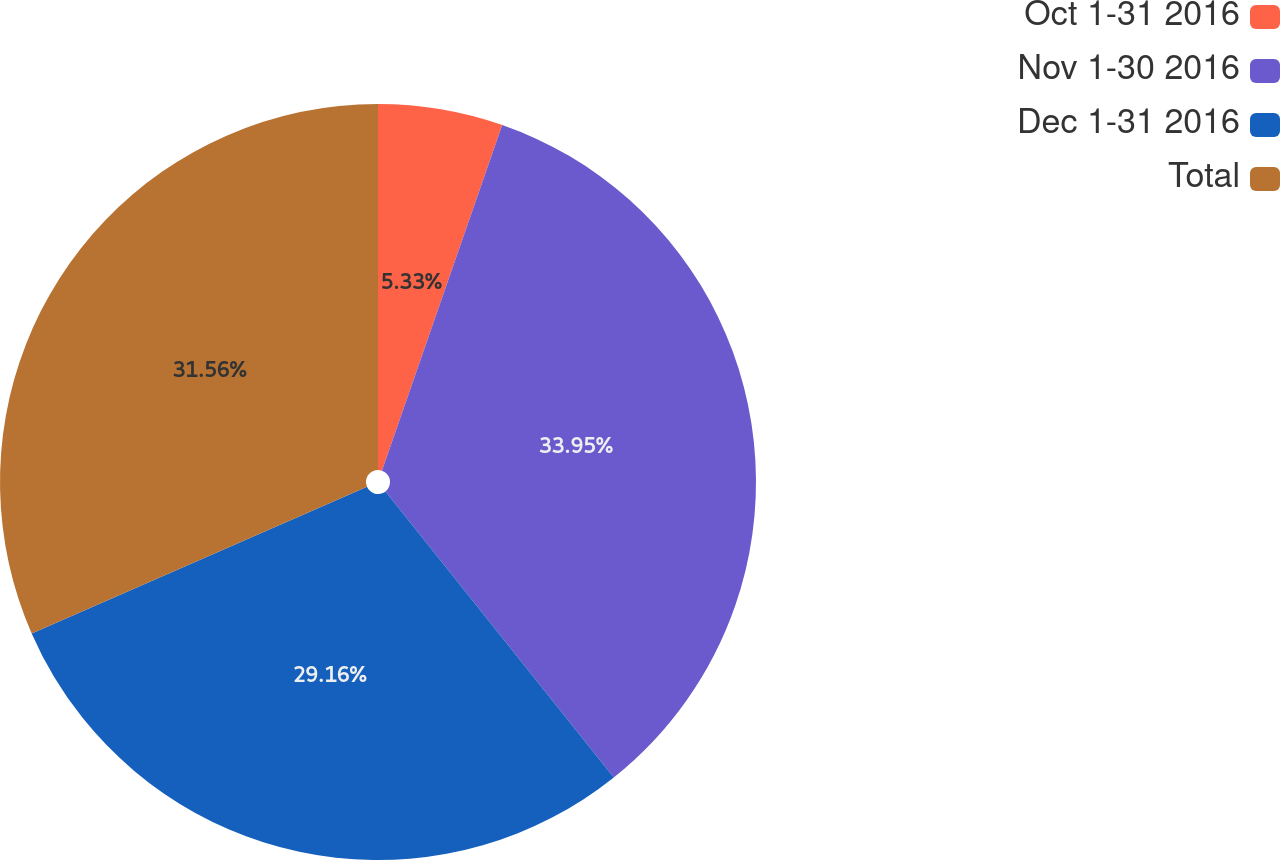<chart> <loc_0><loc_0><loc_500><loc_500><pie_chart><fcel>Oct 1-31 2016<fcel>Nov 1-30 2016<fcel>Dec 1-31 2016<fcel>Total<nl><fcel>5.33%<fcel>33.95%<fcel>29.16%<fcel>31.56%<nl></chart> 